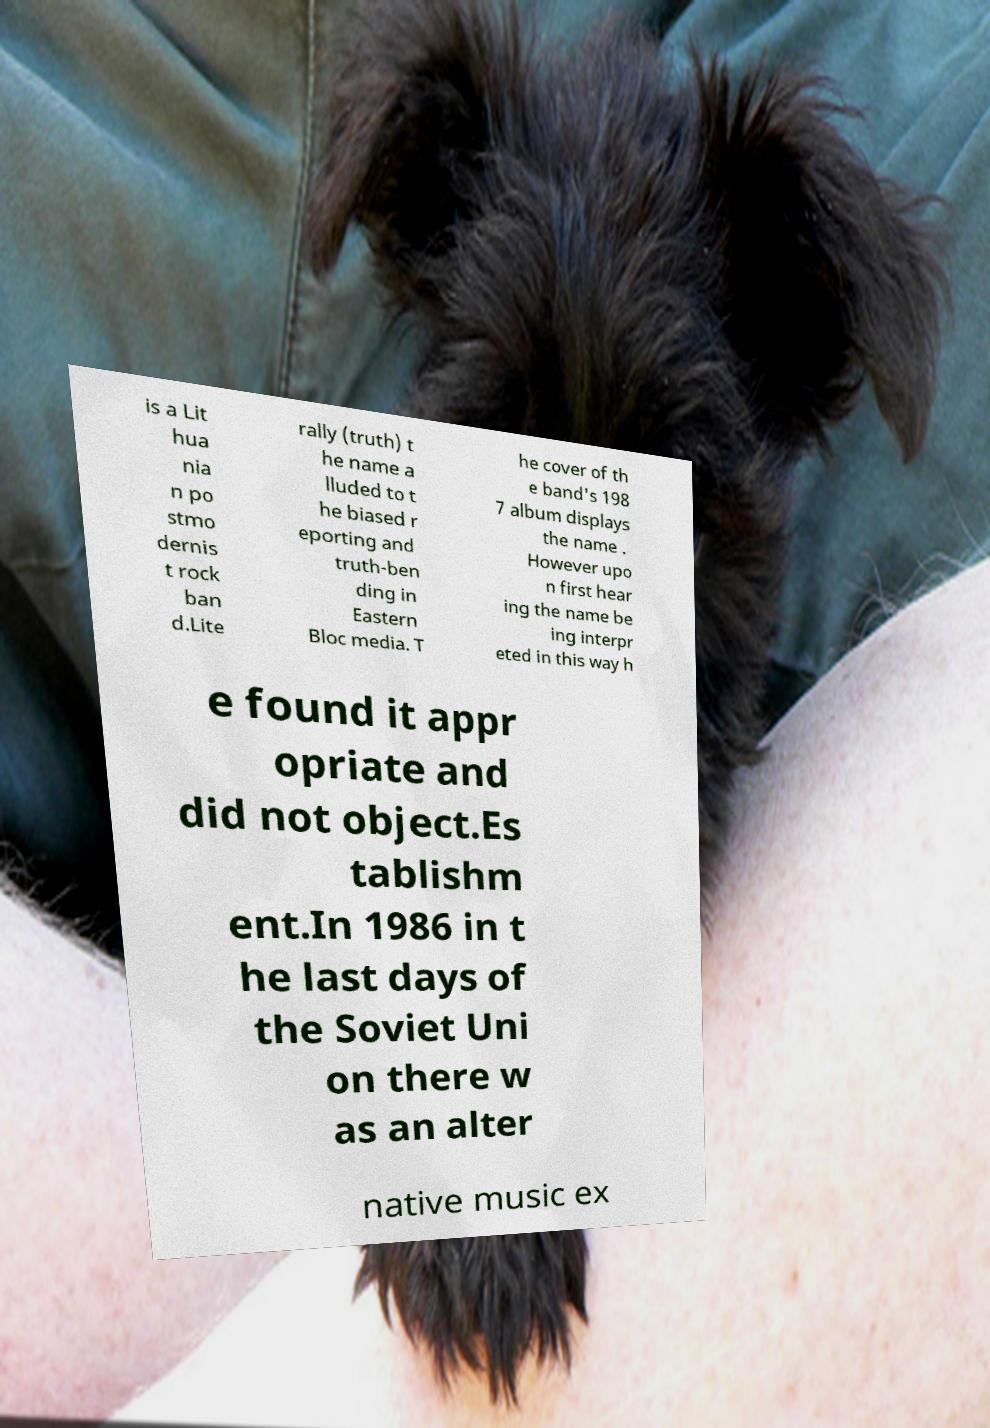What messages or text are displayed in this image? I need them in a readable, typed format. is a Lit hua nia n po stmo dernis t rock ban d.Lite rally (truth) t he name a lluded to t he biased r eporting and truth-ben ding in Eastern Bloc media. T he cover of th e band's 198 7 album displays the name . However upo n first hear ing the name be ing interpr eted in this way h e found it appr opriate and did not object.Es tablishm ent.In 1986 in t he last days of the Soviet Uni on there w as an alter native music ex 